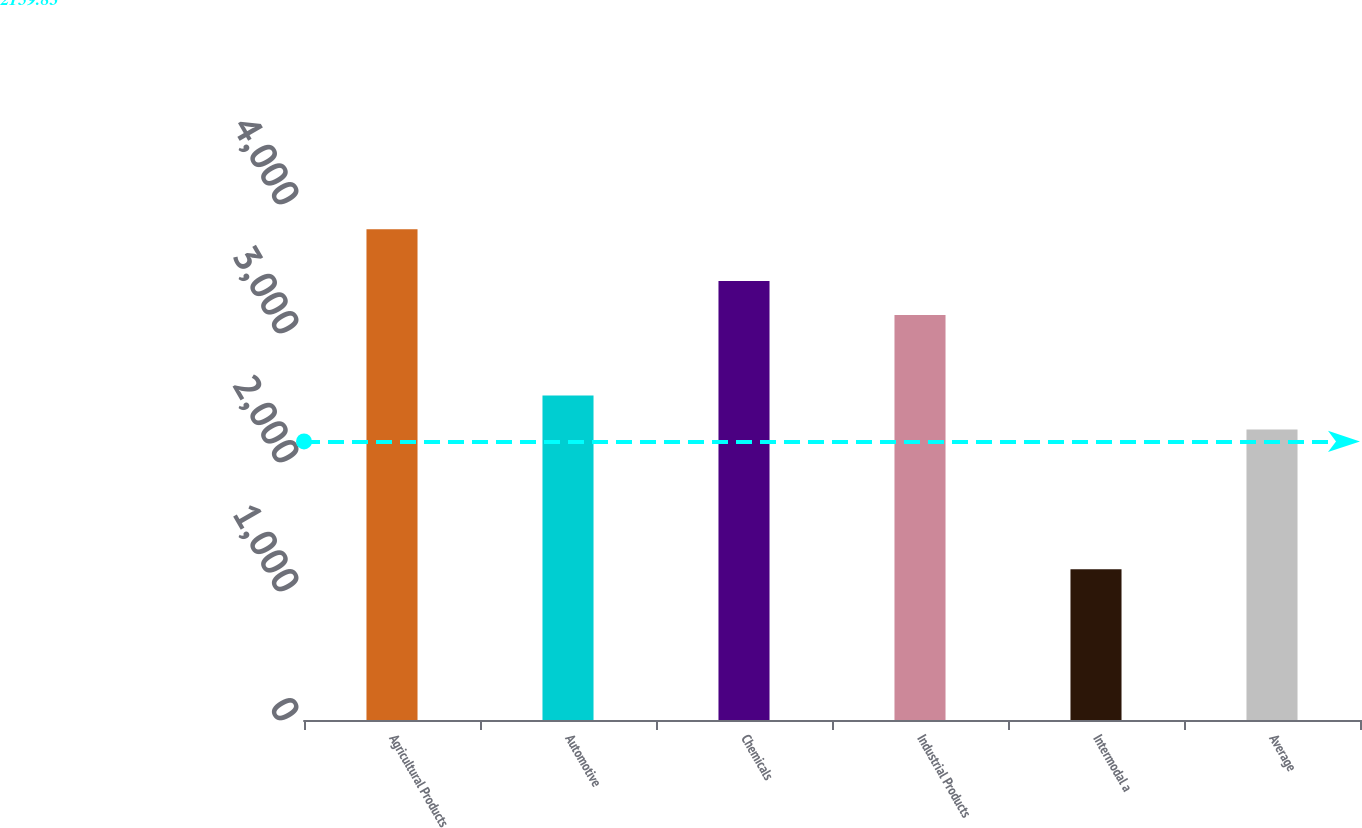Convert chart to OTSL. <chart><loc_0><loc_0><loc_500><loc_500><bar_chart><fcel>Agricultural Products<fcel>Automotive<fcel>Chemicals<fcel>Industrial Products<fcel>Intermodal a<fcel>Average<nl><fcel>3805<fcel>2514.7<fcel>3402.7<fcel>3139<fcel>1168<fcel>2251<nl></chart> 